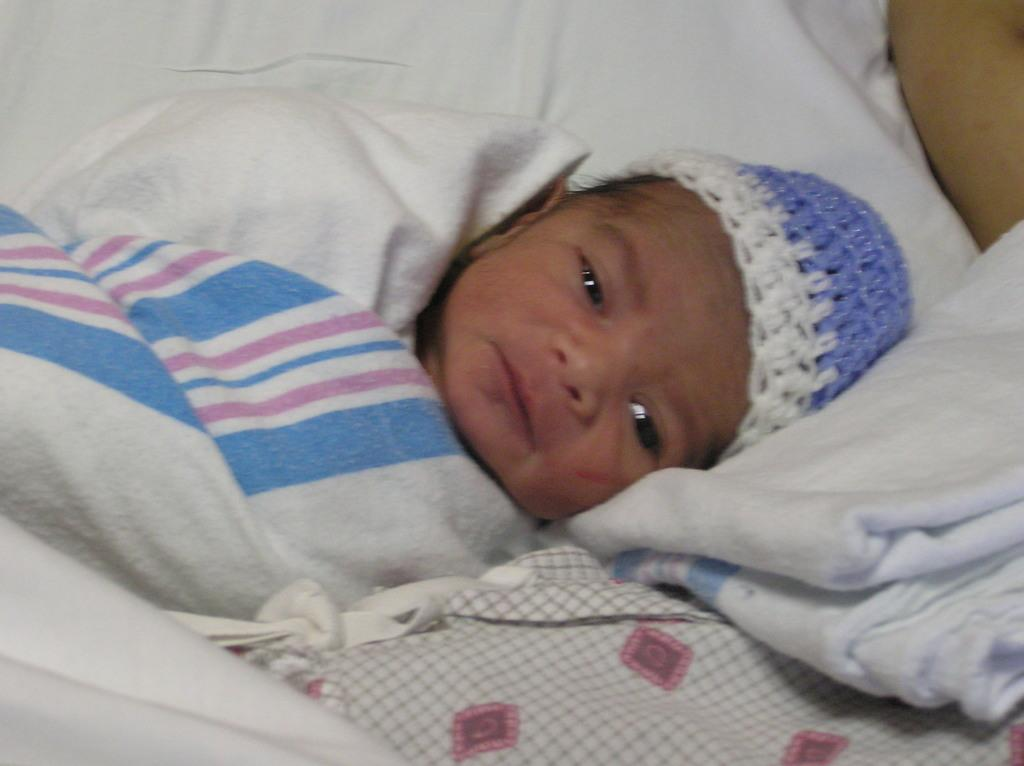What is the main subject of the picture? The main subject of the picture is a baby. What is the baby wearing on their head? The baby is wearing a cap. What is the baby lying on? The baby is lying on a white cloth. Whose hand is visible in the picture? A person's hand is visible in the picture. What else can be seen in the image besides the baby and the hand? There are clothes present in the image. What type of coil is being used to hold the baby's cap in place? There is no coil present in the image; the baby is simply wearing a cap. Is there any oil visible in the picture? No, there is no oil visible in the picture. 